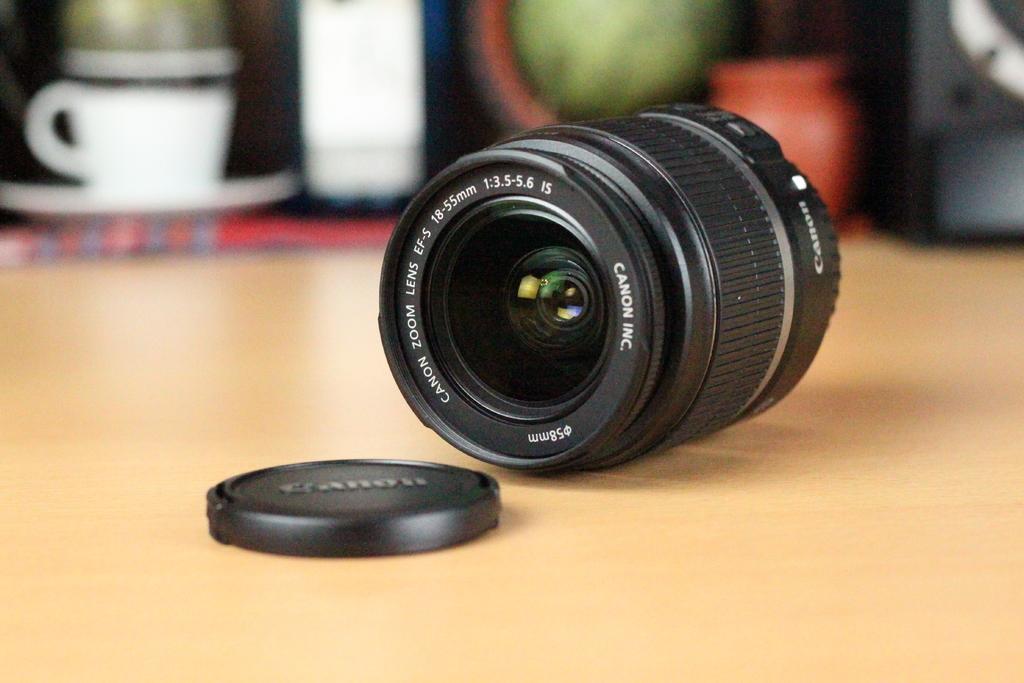Please provide a concise description of this image. As we can see in the image there is a table. On table there is a camera, cup and saucer. The background is little blurred. 